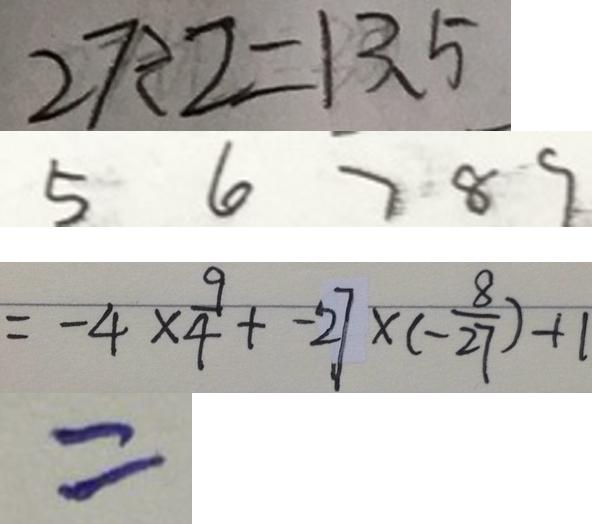Convert formula to latex. <formula><loc_0><loc_0><loc_500><loc_500>2 7 \div 2 = 1 3 . 5 
 5 6 7 8 9 
 = - 4 \times \frac { 9 } { 4 } + - 2 7 \times ( - \frac { 8 } { 2 7 } ) + 1 
 =</formula> 